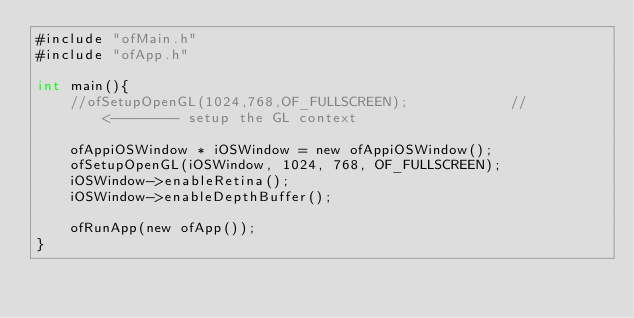<code> <loc_0><loc_0><loc_500><loc_500><_ObjectiveC_>#include "ofMain.h"
#include "ofApp.h"

int main(){
	//ofSetupOpenGL(1024,768,OF_FULLSCREEN);			// <-------- setup the GL context

    ofAppiOSWindow * iOSWindow = new ofAppiOSWindow();
    ofSetupOpenGL(iOSWindow, 1024, 768, OF_FULLSCREEN);
    iOSWindow->enableRetina();
    iOSWindow->enableDepthBuffer();
    
	ofRunApp(new ofApp());
}
</code> 